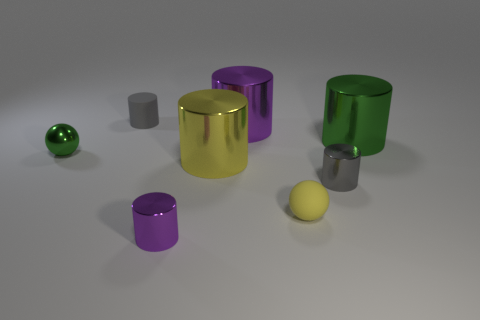Subtract 1 cylinders. How many cylinders are left? 5 Subtract all purple cylinders. How many cylinders are left? 4 Subtract all purple shiny cylinders. How many cylinders are left? 4 Subtract all blue cylinders. Subtract all green balls. How many cylinders are left? 6 Add 1 small yellow metal objects. How many objects exist? 9 Subtract all cylinders. How many objects are left? 2 Subtract 0 cyan blocks. How many objects are left? 8 Subtract all small green objects. Subtract all tiny rubber cylinders. How many objects are left? 6 Add 6 small yellow matte things. How many small yellow matte things are left? 7 Add 4 tiny brown matte balls. How many tiny brown matte balls exist? 4 